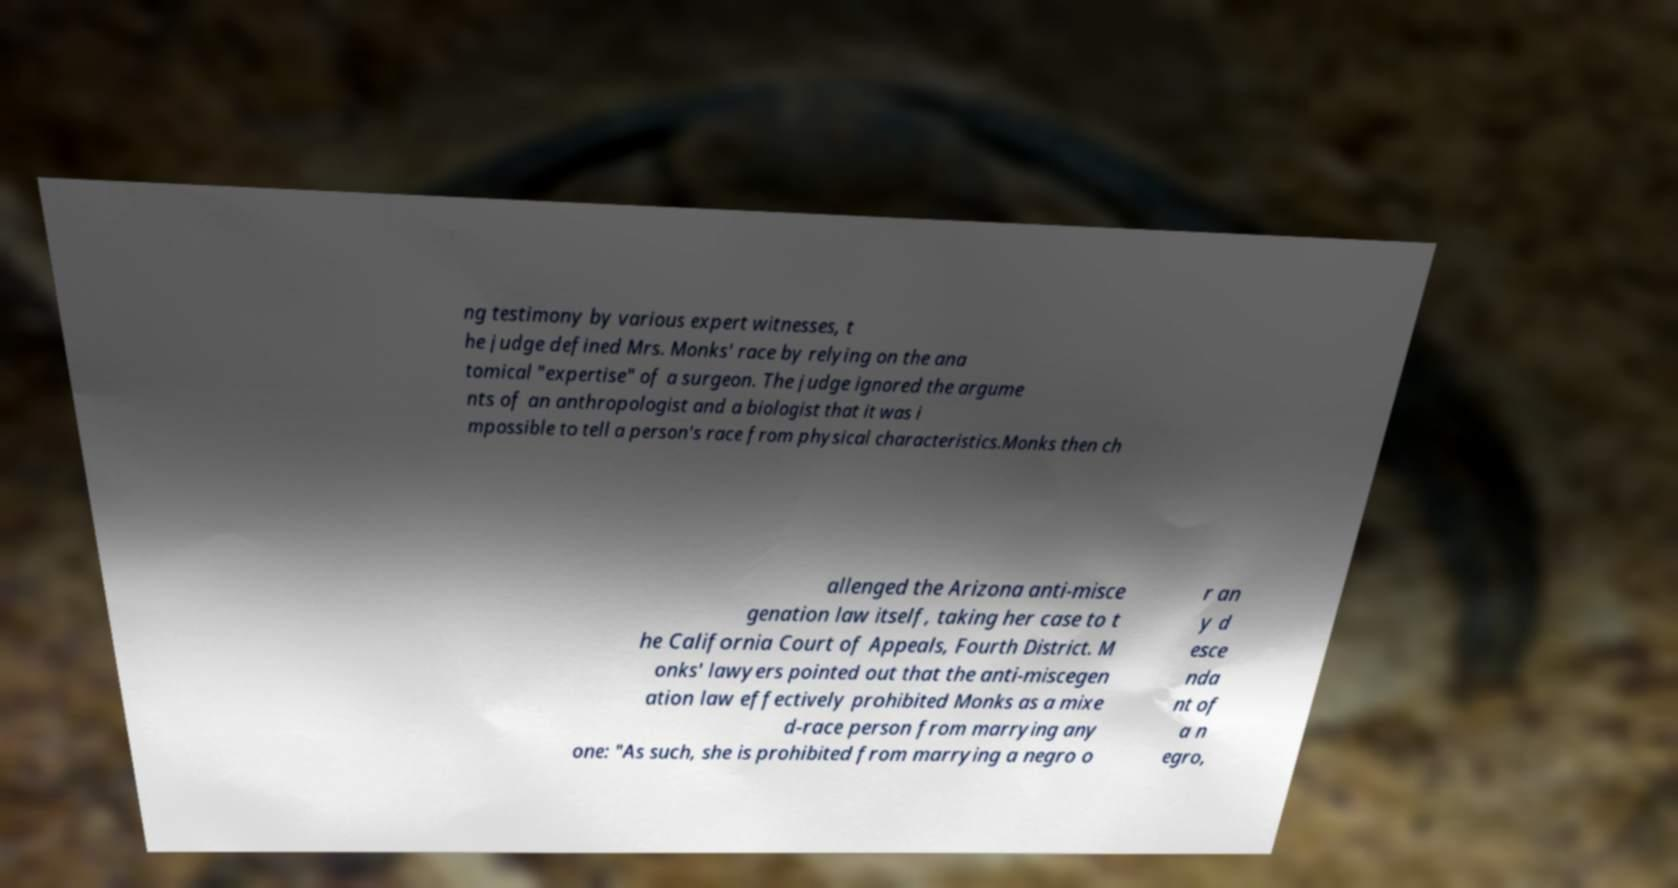Could you extract and type out the text from this image? ng testimony by various expert witnesses, t he judge defined Mrs. Monks' race by relying on the ana tomical "expertise" of a surgeon. The judge ignored the argume nts of an anthropologist and a biologist that it was i mpossible to tell a person's race from physical characteristics.Monks then ch allenged the Arizona anti-misce genation law itself, taking her case to t he California Court of Appeals, Fourth District. M onks' lawyers pointed out that the anti-miscegen ation law effectively prohibited Monks as a mixe d-race person from marrying any one: "As such, she is prohibited from marrying a negro o r an y d esce nda nt of a n egro, 